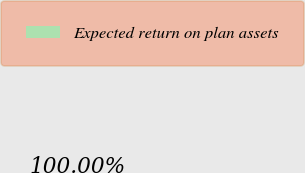Convert chart. <chart><loc_0><loc_0><loc_500><loc_500><pie_chart><fcel>Expected return on plan assets<nl><fcel>100.0%<nl></chart> 